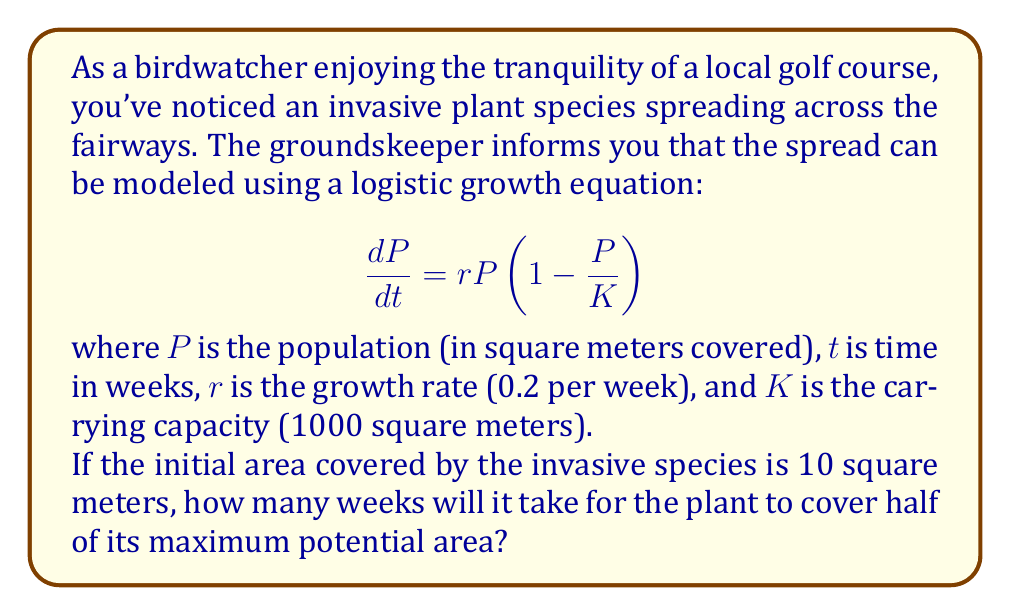Teach me how to tackle this problem. To solve this problem, we'll use the logistic growth model and its solution. The steps are as follows:

1) The solution to the logistic growth equation is:

   $$P(t) = \frac{K}{1 + (\frac{K}{P_0} - 1)e^{-rt}}$$

   where $P_0$ is the initial population.

2) We're asked to find when $P(t) = \frac{K}{2} = 500$ square meters.

3) Let's substitute the known values:
   $K = 1000$, $P_0 = 10$, $r = 0.2$

4) Now we can set up the equation:

   $$500 = \frac{1000}{1 + (\frac{1000}{10} - 1)e^{-0.2t}}$$

5) Simplify:

   $$500 = \frac{1000}{1 + 99e^{-0.2t}}$$

6) Multiply both sides by $(1 + 99e^{-0.2t})$:

   $$500 + 49500e^{-0.2t} = 1000$$

7) Subtract 500 from both sides:

   $$49500e^{-0.2t} = 500$$

8) Divide both sides by 49500:

   $$e^{-0.2t} = \frac{1}{99}$$

9) Take the natural log of both sides:

   $$-0.2t = \ln(\frac{1}{99}) = -\ln(99)$$

10) Divide both sides by -0.2:

    $$t = \frac{\ln(99)}{0.2} \approx 23.025$$

Therefore, it will take approximately 23 weeks for the invasive plant to cover half of its maximum potential area.
Answer: Approximately 23 weeks 